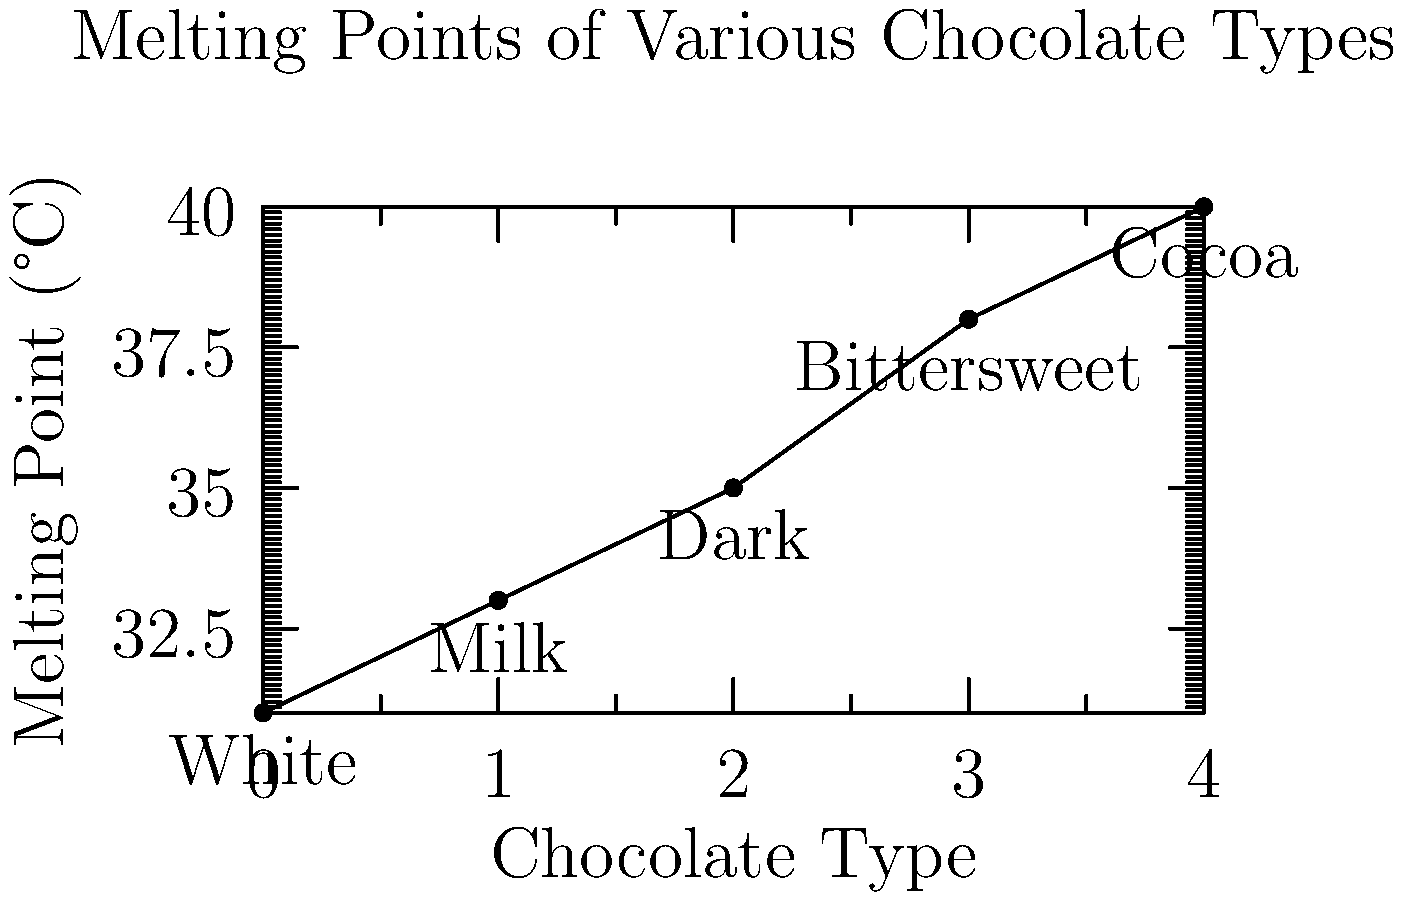As a chocolate connoisseur eagerly awaiting new product launches, you're analyzing the melting points of different chocolate types. Based on the line graph showing the melting points of various chocolate types, estimate the melting point of a new dark chocolate bar that contains 75% cocoa solids. To estimate the melting point of a 75% cocoa dark chocolate bar, we need to follow these steps:

1. Identify the relevant data points on the graph:
   - Dark chocolate: 35°C
   - Bittersweet chocolate: 38°C

2. Understand the relationship between cocoa content and melting point:
   - As cocoa content increases, the melting point generally increases.
   - Dark chocolate typically has 50-70% cocoa solids.
   - Bittersweet chocolate usually has 70-100% cocoa solids.

3. Interpolate between dark and bittersweet chocolate:
   - The 75% cocoa chocolate falls between dark and bittersweet.
   - It's closer to bittersweet (70-100%) than standard dark chocolate (50-70%).

4. Estimate the melting point:
   - The melting point should be between 35°C and 38°C.
   - Since 75% is about halfway between typical dark and bittersweet chocolates, we can estimate the melting point to be approximately halfway between 35°C and 38°C.

5. Calculate the estimated melting point:
   $\text{Estimated Melting Point} = 35°C + \frac{38°C - 35°C}{2} = 35°C + 1.5°C = 36.5°C$

Therefore, we can estimate that the melting point of a 75% cocoa dark chocolate bar would be approximately 36.5°C.
Answer: 36.5°C 